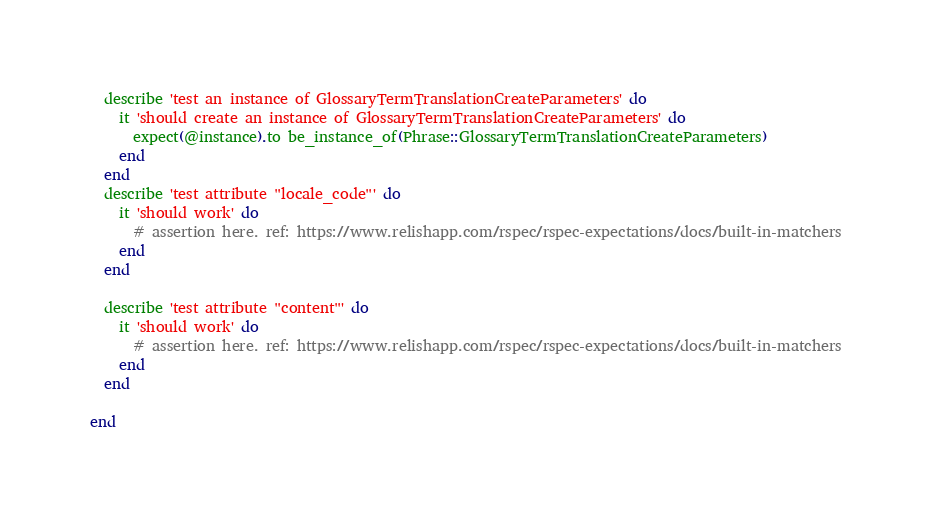Convert code to text. <code><loc_0><loc_0><loc_500><loc_500><_Ruby_>
  describe 'test an instance of GlossaryTermTranslationCreateParameters' do
    it 'should create an instance of GlossaryTermTranslationCreateParameters' do
      expect(@instance).to be_instance_of(Phrase::GlossaryTermTranslationCreateParameters)
    end
  end
  describe 'test attribute "locale_code"' do
    it 'should work' do
      # assertion here. ref: https://www.relishapp.com/rspec/rspec-expectations/docs/built-in-matchers
    end
  end

  describe 'test attribute "content"' do
    it 'should work' do
      # assertion here. ref: https://www.relishapp.com/rspec/rspec-expectations/docs/built-in-matchers
    end
  end

end
</code> 